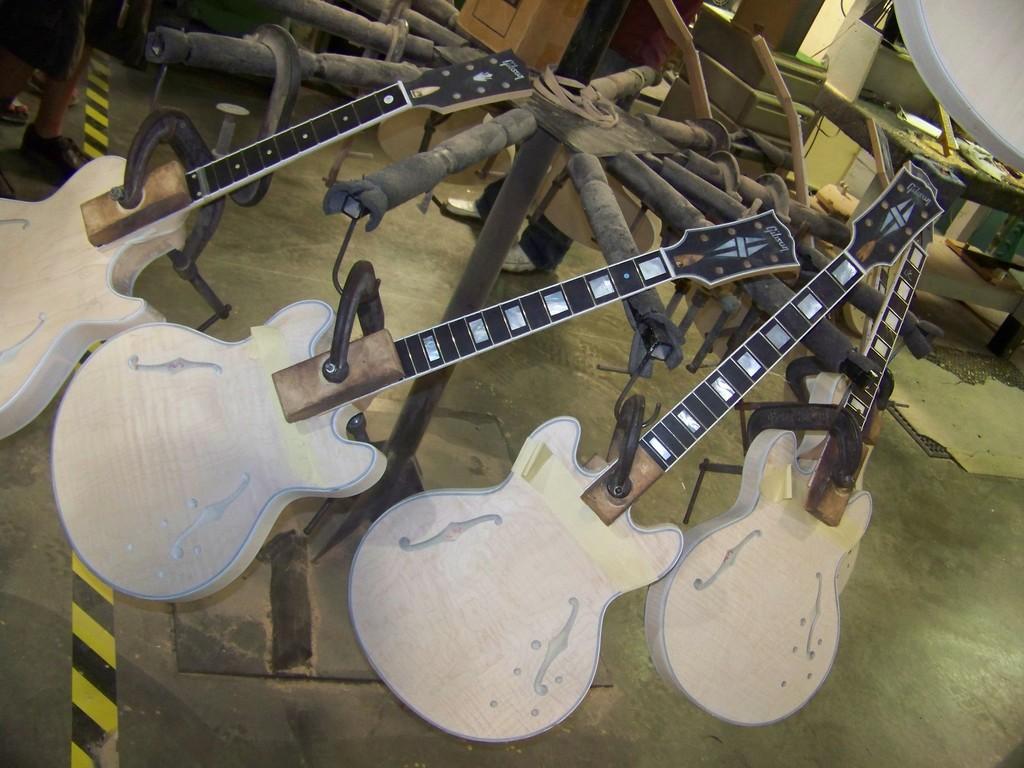Can you describe this image briefly? This image consist of guitars. There are, there is a table on the right side. 